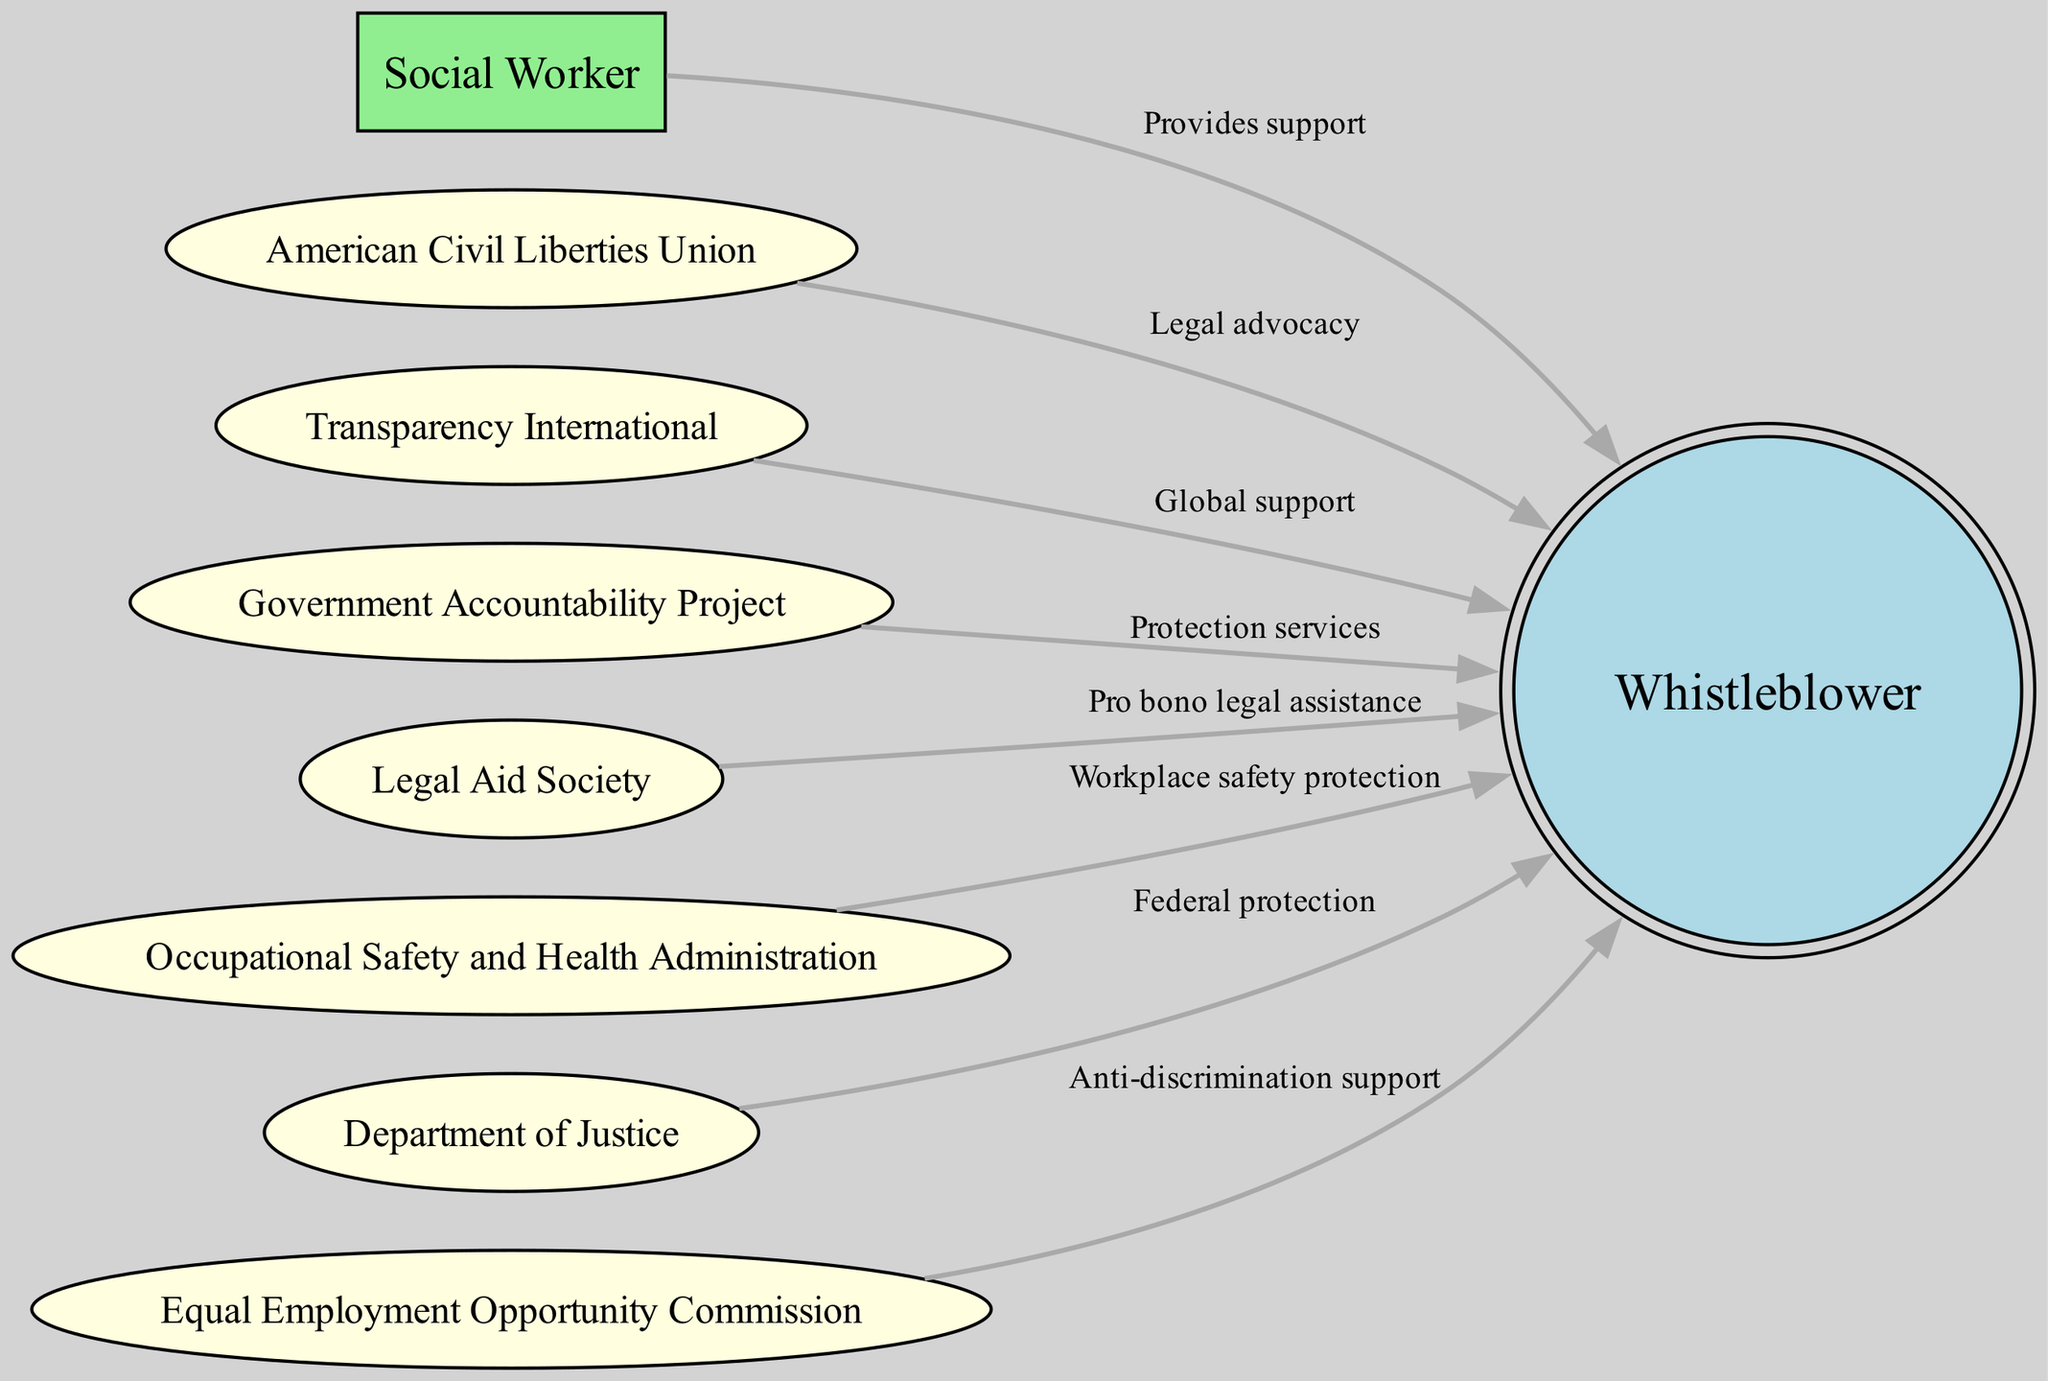What is the total number of nodes in the diagram? The diagram contains multiple nodes representing different stakeholders involved in supporting whistleblowers. By counting the nodes listed in the data section, we find there are eight nodes in total.
Answer: 8 Which entity provides pro bono legal assistance to whistleblowers? In the diagram, the Legal Aid Society is indicated as providing pro bono legal assistance, according to the edge connecting it to the whistleblower node.
Answer: Legal Aid Society Who provides workplace safety protection? The Occupational Safety and Health Administration is shown in the diagram as the entity that provides workplace safety protection to whistleblowers based on its connection to the whistleblower node.
Answer: Occupational Safety and Health Administration How many organizations offer legal support to whistleblowers? By examining the edges, we find that multiple organizations are connected to the whistleblower node providing legal support. These include the American Civil Liberties Union and the Legal Aid Society, totaling three entities offering legal support.
Answer: 3 What is the relationship between the Department of Justice and the whistleblower? The edge in the diagram indicates that the Department of Justice provides federal protection to the whistleblower, establishing a clear supportive relationship.
Answer: Federal protection Which organization is associated with global support for whistleblowers? The diagram shows Transparency International connected to the whistleblower node, indicating it offers global support for whistleblowers.
Answer: Transparency International What is the unique role of the American Civil Liberties Union in this network? The American Civil Liberties Union is described in the diagram as providing legal advocacy, which highlights its specific role in supporting whistleblowers within the broader network of stakeholders.
Answer: Legal advocacy How many edges are present in the diagram? By counting the edges connecting the nodes, we identify that there are a total of seven edges in the diagram, illustrating the relationships among the stakeholders.
Answer: 7 What does the social worker provide to the whistleblower? In the diagram, the social worker is shown as providing support to the whistleblower, indicating a supportive role within the network of stakeholders.
Answer: Provides support 